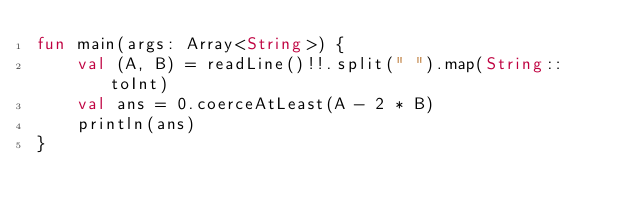Convert code to text. <code><loc_0><loc_0><loc_500><loc_500><_Kotlin_>fun main(args: Array<String>) {
    val (A, B) = readLine()!!.split(" ").map(String::toInt)
    val ans = 0.coerceAtLeast(A - 2 * B)
    println(ans)
}</code> 